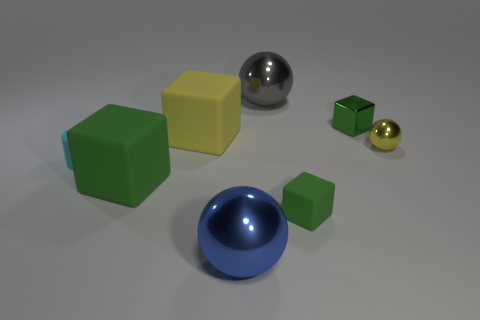What number of objects have the same color as the small sphere?
Provide a short and direct response. 1. Do the rubber thing that is behind the cyan rubber object and the big blue thing in front of the big gray sphere have the same shape?
Make the answer very short. No. The shiny ball behind the small yellow sphere that is to the right of the big rubber object that is to the left of the big yellow matte object is what color?
Your response must be concise. Gray. What color is the tiny metal ball to the right of the cylinder?
Ensure brevity in your answer.  Yellow. What color is the metallic ball that is the same size as the gray metal object?
Keep it short and to the point. Blue. Do the blue metal object and the cyan matte cylinder have the same size?
Provide a short and direct response. No. There is a tiny yellow ball; what number of small cubes are in front of it?
Keep it short and to the point. 1. How many things are big blocks to the left of the small yellow sphere or tiny cyan cylinders?
Your response must be concise. 3. Are there more small rubber objects behind the small rubber block than tiny green matte cubes that are behind the yellow rubber cube?
Your answer should be compact. Yes. There is a cube that is the same color as the tiny ball; what size is it?
Your answer should be compact. Large. 